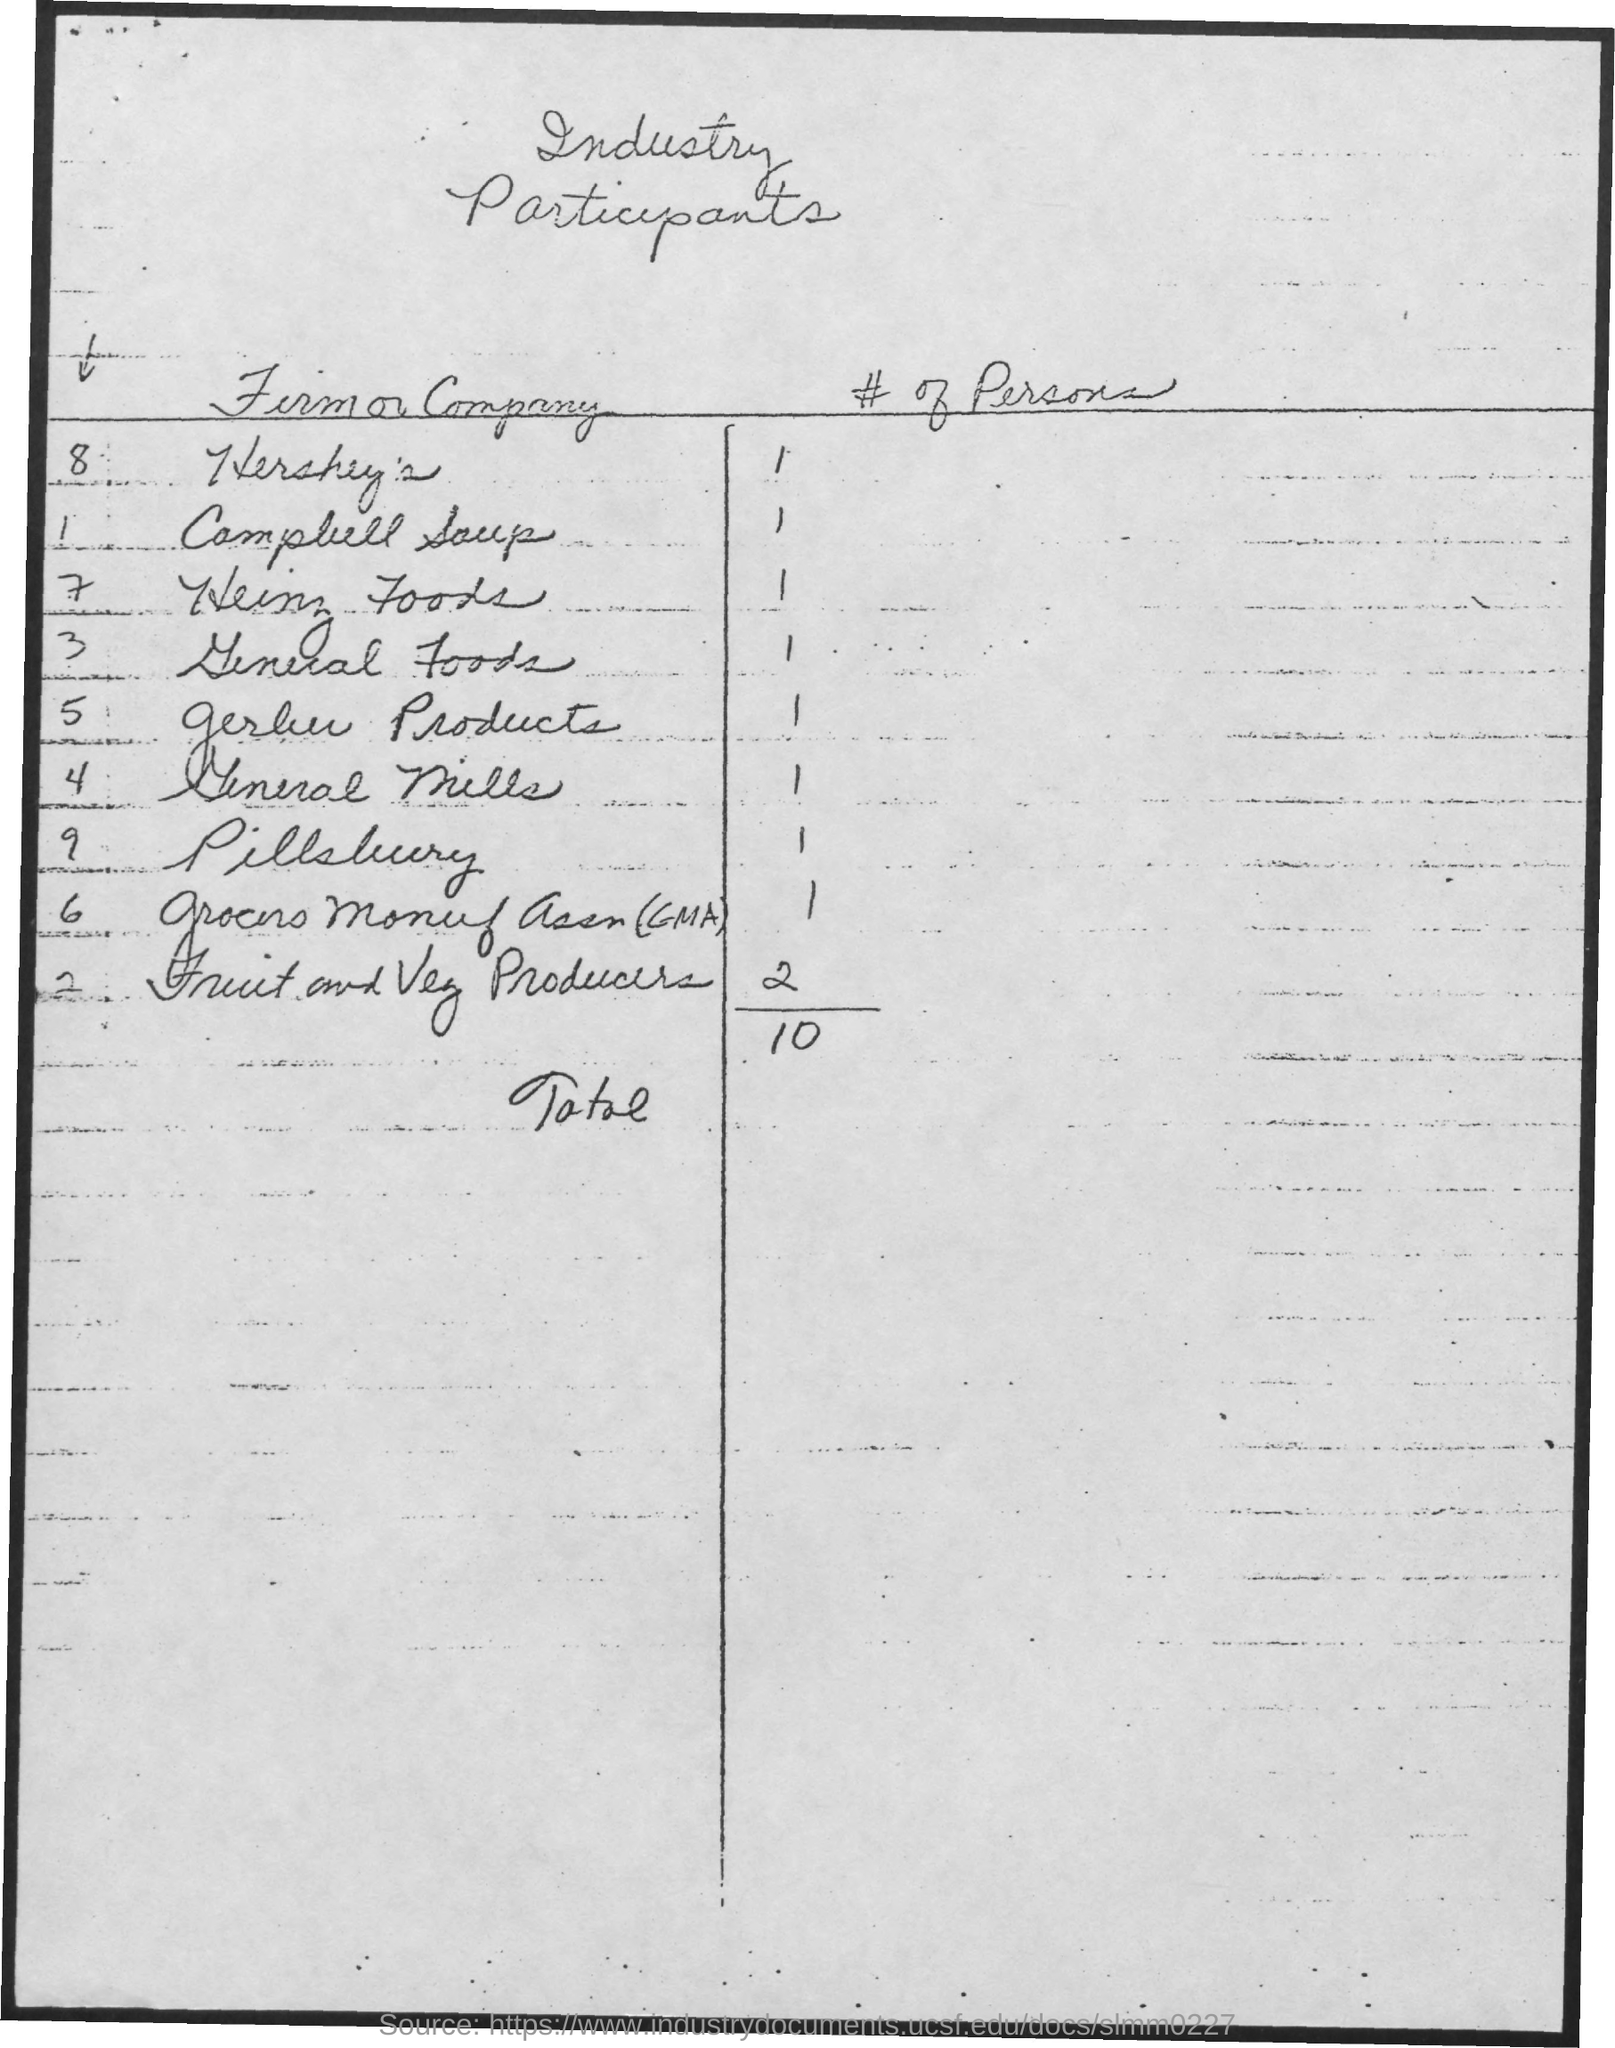What is the table title?
Keep it short and to the point. Industry participants. How many participants are there in total?
Your answer should be very brief. 10. Which firm/company has the most number of participants?
Offer a terse response. Fruit and Veg Producers. 